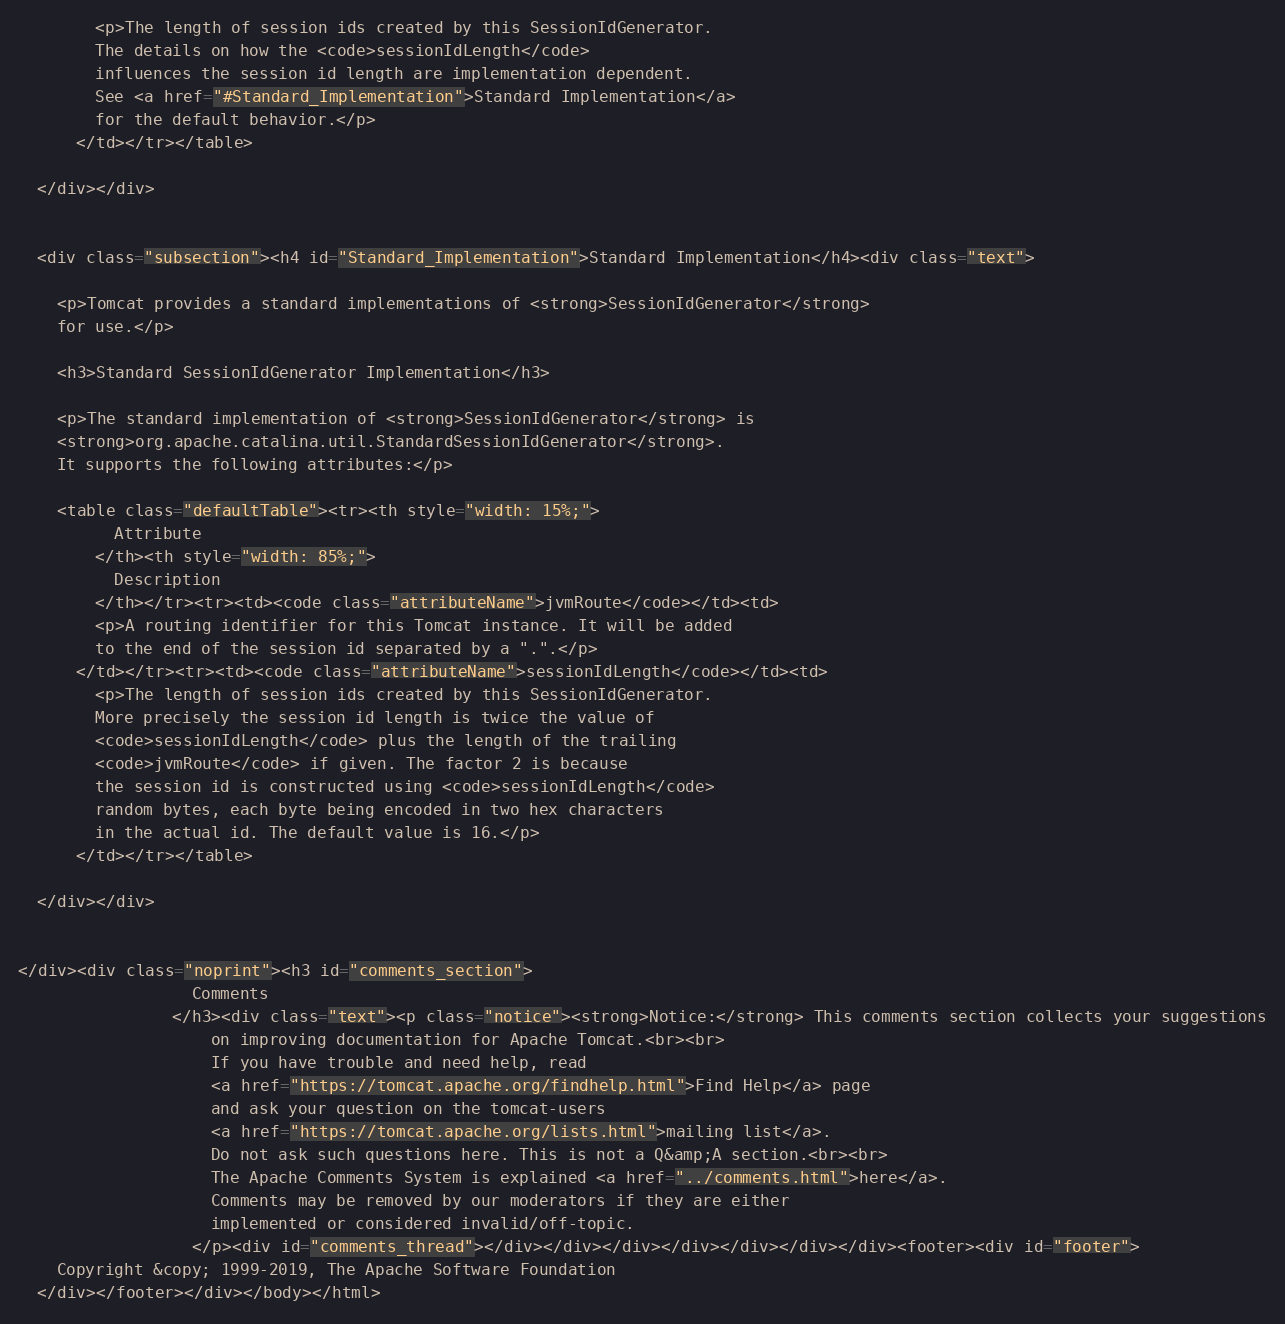Convert code to text. <code><loc_0><loc_0><loc_500><loc_500><_HTML_>        <p>The length of session ids created by this SessionIdGenerator.
        The details on how the <code>sessionIdLength</code>
        influences the session id length are implementation dependent.
        See <a href="#Standard_Implementation">Standard Implementation</a>
        for the default behavior.</p>
      </td></tr></table>

  </div></div>


  <div class="subsection"><h4 id="Standard_Implementation">Standard Implementation</h4><div class="text">

    <p>Tomcat provides a standard implementations of <strong>SessionIdGenerator</strong>
    for use.</p>

    <h3>Standard SessionIdGenerator Implementation</h3>

    <p>The standard implementation of <strong>SessionIdGenerator</strong> is
    <strong>org.apache.catalina.util.StandardSessionIdGenerator</strong>.
    It supports the following attributes:</p>

    <table class="defaultTable"><tr><th style="width: 15%;">
          Attribute
        </th><th style="width: 85%;">
          Description
        </th></tr><tr><td><code class="attributeName">jvmRoute</code></td><td>
        <p>A routing identifier for this Tomcat instance. It will be added
        to the end of the session id separated by a ".".</p>
      </td></tr><tr><td><code class="attributeName">sessionIdLength</code></td><td>
        <p>The length of session ids created by this SessionIdGenerator.
        More precisely the session id length is twice the value of
        <code>sessionIdLength</code> plus the length of the trailing
        <code>jvmRoute</code> if given. The factor 2 is because
        the session id is constructed using <code>sessionIdLength</code>
        random bytes, each byte being encoded in two hex characters
        in the actual id. The default value is 16.</p>
      </td></tr></table>

  </div></div>


</div><div class="noprint"><h3 id="comments_section">
                  Comments
                </h3><div class="text"><p class="notice"><strong>Notice:</strong> This comments section collects your suggestions
                    on improving documentation for Apache Tomcat.<br><br>
                    If you have trouble and need help, read
                    <a href="https://tomcat.apache.org/findhelp.html">Find Help</a> page
                    and ask your question on the tomcat-users
                    <a href="https://tomcat.apache.org/lists.html">mailing list</a>.
                    Do not ask such questions here. This is not a Q&amp;A section.<br><br>
                    The Apache Comments System is explained <a href="../comments.html">here</a>.
                    Comments may be removed by our moderators if they are either
                    implemented or considered invalid/off-topic.
                  </p><div id="comments_thread"></div></div></div></div></div></div></div><footer><div id="footer">
    Copyright &copy; 1999-2019, The Apache Software Foundation
  </div></footer></div></body></html></code> 